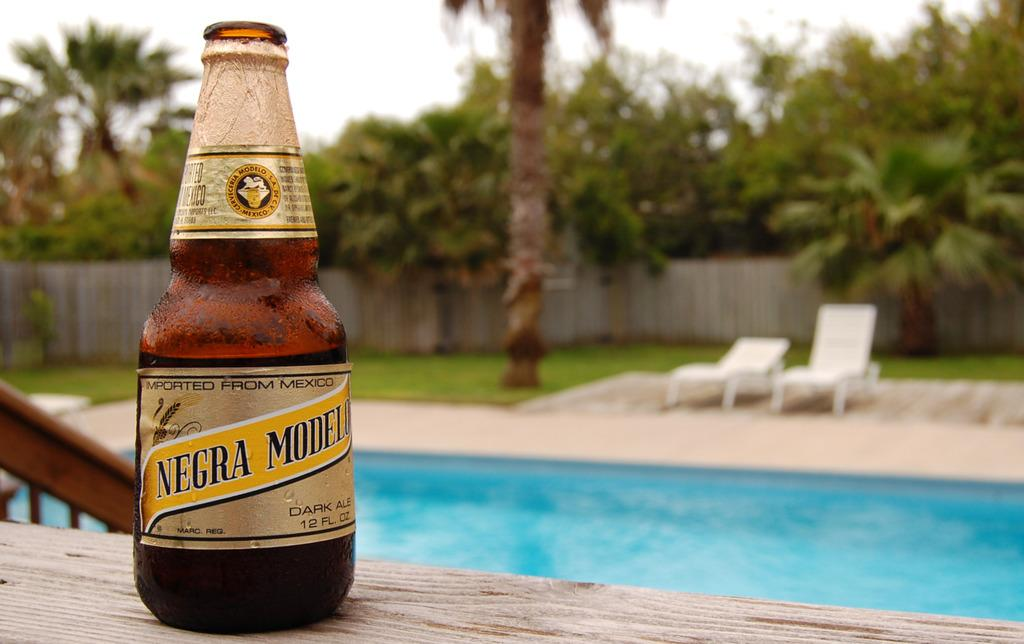<image>
Offer a succinct explanation of the picture presented. A bottle of Negra Modelo is on a table with a pool in the background. 